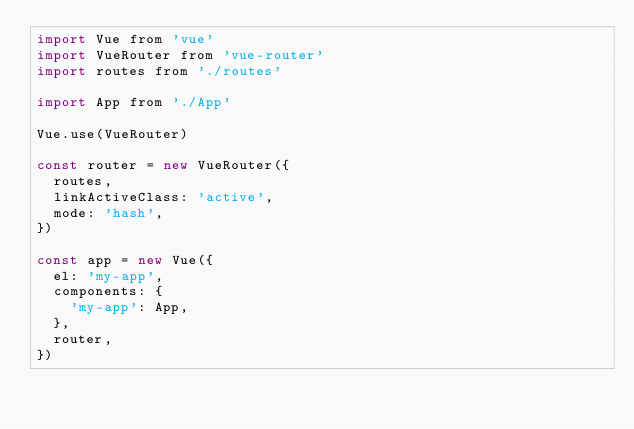Convert code to text. <code><loc_0><loc_0><loc_500><loc_500><_JavaScript_>import Vue from 'vue'
import VueRouter from 'vue-router'
import routes from './routes'

import App from './App'

Vue.use(VueRouter)

const router = new VueRouter({
  routes,
  linkActiveClass: 'active',
  mode: 'hash',
})

const app = new Vue({
  el: 'my-app',
  components: {
    'my-app': App,
  },
  router,
})
</code> 